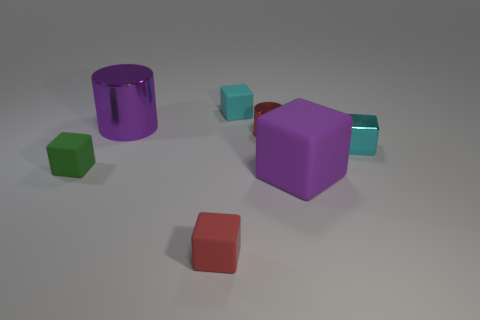What shape is the thing that is the same size as the purple cylinder?
Keep it short and to the point. Cube. Are there any large purple objects that have the same shape as the cyan metal thing?
Your response must be concise. Yes. Is the number of small green matte cubes less than the number of metal things?
Your response must be concise. Yes. There is a purple thing that is left of the small red rubber object; is it the same size as the cylinder right of the red cube?
Make the answer very short. No. How many objects are either small yellow metallic spheres or tiny cylinders?
Offer a very short reply. 1. There is a matte cube that is in front of the large purple rubber cube; what size is it?
Your response must be concise. Small. There is a large purple object in front of the tiny cyan cube that is in front of the purple shiny cylinder; what number of purple rubber cubes are behind it?
Your answer should be very brief. 0. Do the big metallic cylinder and the large rubber cube have the same color?
Your response must be concise. Yes. How many tiny rubber objects are both behind the small red block and in front of the large purple matte thing?
Offer a very short reply. 0. What shape is the red thing that is in front of the tiny cylinder?
Make the answer very short. Cube. 